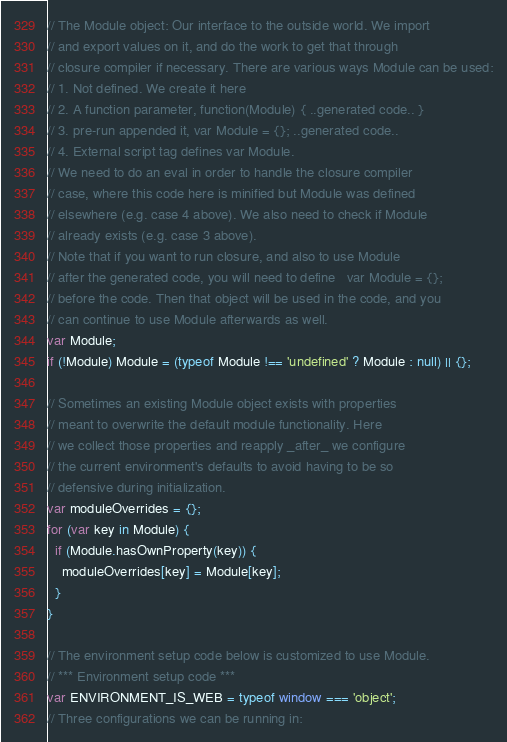Convert code to text. <code><loc_0><loc_0><loc_500><loc_500><_JavaScript_>// The Module object: Our interface to the outside world. We import
// and export values on it, and do the work to get that through
// closure compiler if necessary. There are various ways Module can be used:
// 1. Not defined. We create it here
// 2. A function parameter, function(Module) { ..generated code.. }
// 3. pre-run appended it, var Module = {}; ..generated code..
// 4. External script tag defines var Module.
// We need to do an eval in order to handle the closure compiler
// case, where this code here is minified but Module was defined
// elsewhere (e.g. case 4 above). We also need to check if Module
// already exists (e.g. case 3 above).
// Note that if you want to run closure, and also to use Module
// after the generated code, you will need to define   var Module = {};
// before the code. Then that object will be used in the code, and you
// can continue to use Module afterwards as well.
var Module;
if (!Module) Module = (typeof Module !== 'undefined' ? Module : null) || {};

// Sometimes an existing Module object exists with properties
// meant to overwrite the default module functionality. Here
// we collect those properties and reapply _after_ we configure
// the current environment's defaults to avoid having to be so
// defensive during initialization.
var moduleOverrides = {};
for (var key in Module) {
  if (Module.hasOwnProperty(key)) {
    moduleOverrides[key] = Module[key];
  }
}

// The environment setup code below is customized to use Module.
// *** Environment setup code ***
var ENVIRONMENT_IS_WEB = typeof window === 'object';
// Three configurations we can be running in:</code> 